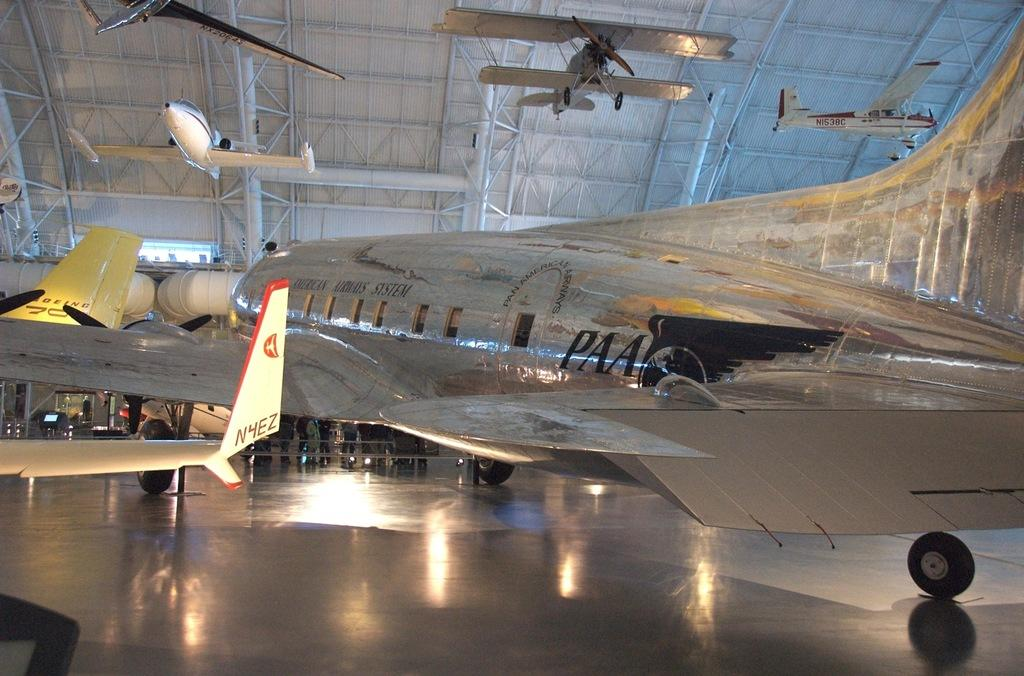What is placed on the floor in the image? There is an airplane on the floor in the image. What can be seen behind the airplane on the floor? There are people standing behind the airplane. What is visible at the top of the image? There are airplanes visible at the top of the image. Can you tell me how many yaks are present in the image? There are no yaks present in the image. Where is the birth of the airplane depicted in the image? The image does not depict the birth of an airplane; it shows an airplane on the floor and people standing behind it. 